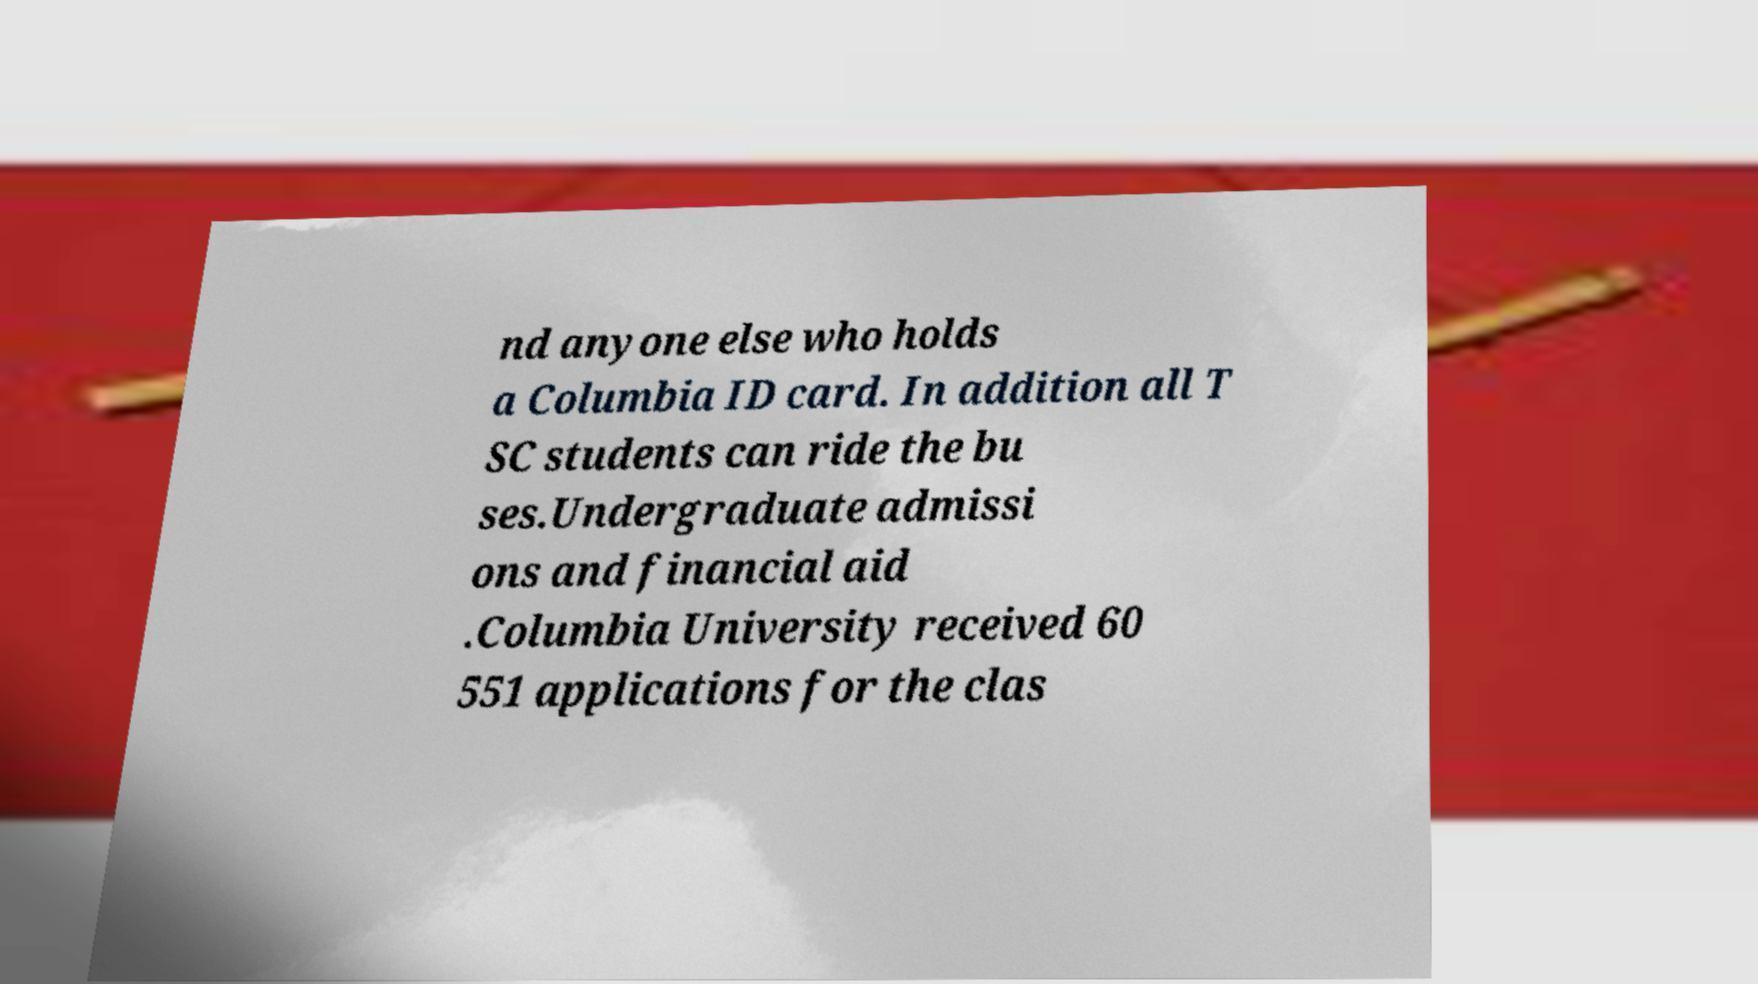Please read and relay the text visible in this image. What does it say? nd anyone else who holds a Columbia ID card. In addition all T SC students can ride the bu ses.Undergraduate admissi ons and financial aid .Columbia University received 60 551 applications for the clas 